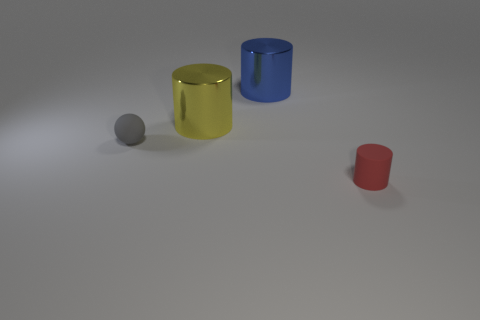What is the color of the tiny ball? gray 